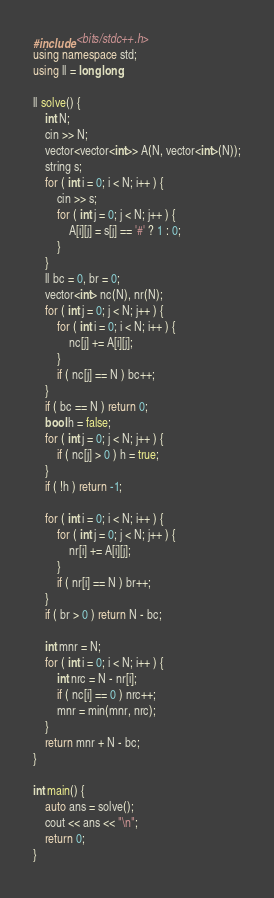Convert code to text. <code><loc_0><loc_0><loc_500><loc_500><_C++_>#include <bits/stdc++.h>
using namespace std;
using ll = long long;

ll solve() {
    int N;
    cin >> N;
    vector<vector<int>> A(N, vector<int>(N));
    string s;
    for ( int i = 0; i < N; i++ ) {
        cin >> s;
        for ( int j = 0; j < N; j++ ) {
            A[i][j] = s[j] == '#' ? 1 : 0;
        }
    }
    ll bc = 0, br = 0;
    vector<int> nc(N), nr(N);
    for ( int j = 0; j < N; j++ ) {
        for ( int i = 0; i < N; i++ ) {
            nc[j] += A[i][j];
        }
        if ( nc[j] == N ) bc++;
    }
    if ( bc == N ) return 0;
    bool h = false;
    for ( int j = 0; j < N; j++ ) {
        if ( nc[j] > 0 ) h = true;
    }
    if ( !h ) return -1;

    for ( int i = 0; i < N; i++ ) {
        for ( int j = 0; j < N; j++ ) {
            nr[i] += A[i][j];
        }
        if ( nr[i] == N ) br++;
    }
    if ( br > 0 ) return N - bc;

    int mnr = N;
    for ( int i = 0; i < N; i++ ) {
        int nrc = N - nr[i];
        if ( nc[i] == 0 ) nrc++;
        mnr = min(mnr, nrc);
    }
    return mnr + N - bc;
}

int main() {
    auto ans = solve();
    cout << ans << "\n";
    return 0;
}</code> 